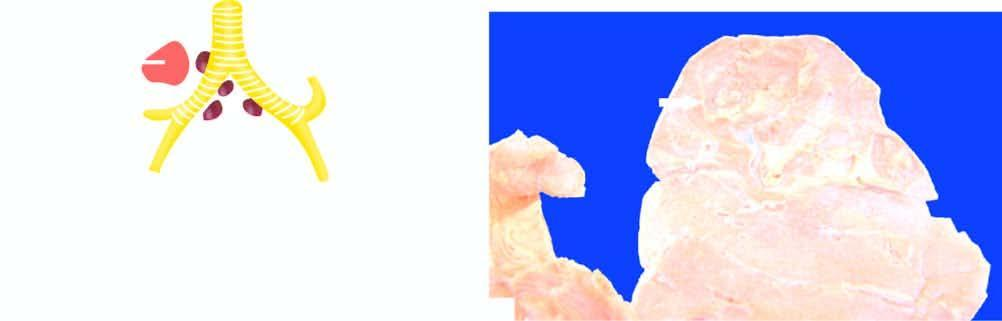s aemosiderin pigment in the cytoplasm of hepatocytes right?
Answer the question using a single word or phrase. No 